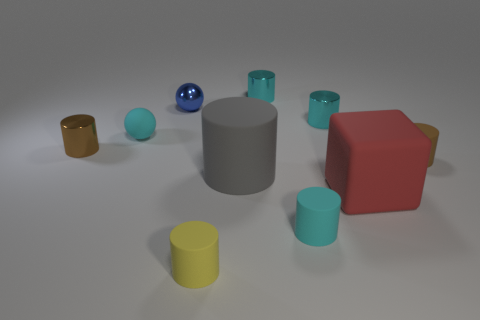Subtract all cyan cylinders. How many cylinders are left? 4 Subtract all cyan cylinders. How many cylinders are left? 4 Subtract all cylinders. How many objects are left? 3 Subtract 6 cylinders. How many cylinders are left? 1 Subtract all gray balls. Subtract all brown cylinders. How many balls are left? 2 Subtract all green spheres. How many yellow blocks are left? 0 Subtract all cyan blocks. Subtract all tiny yellow cylinders. How many objects are left? 9 Add 6 big rubber things. How many big rubber things are left? 8 Add 4 tiny blue shiny things. How many tiny blue shiny things exist? 5 Subtract 0 purple balls. How many objects are left? 10 